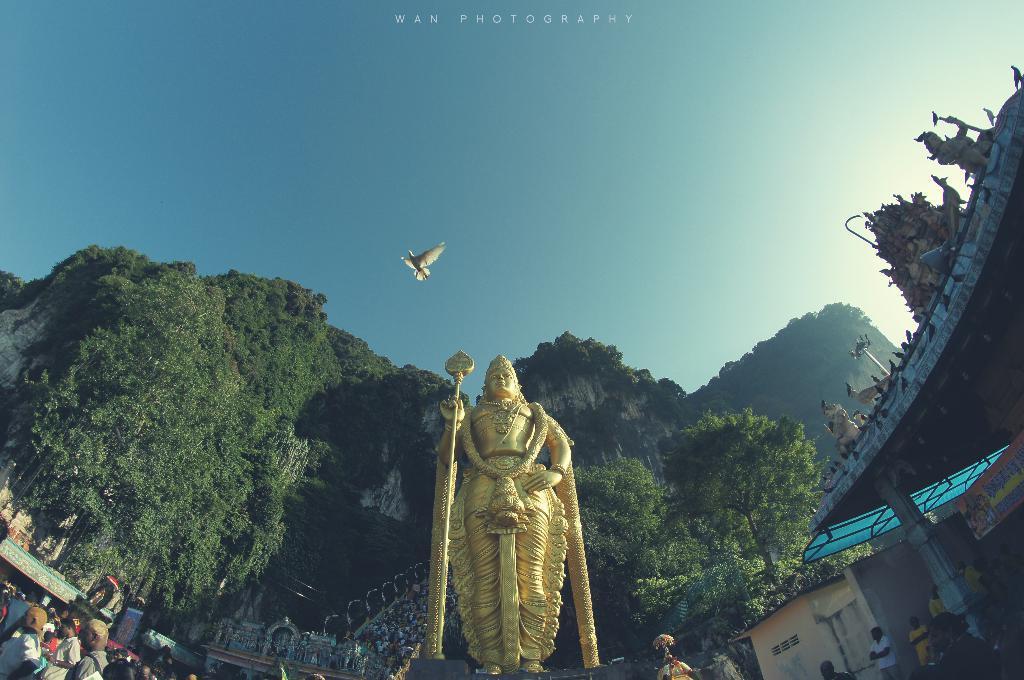Please provide a concise description of this image. In this image I can see a statue, background I can see few persons standing, trees in green color, a bird in white color and the sky is in blue and white color. 